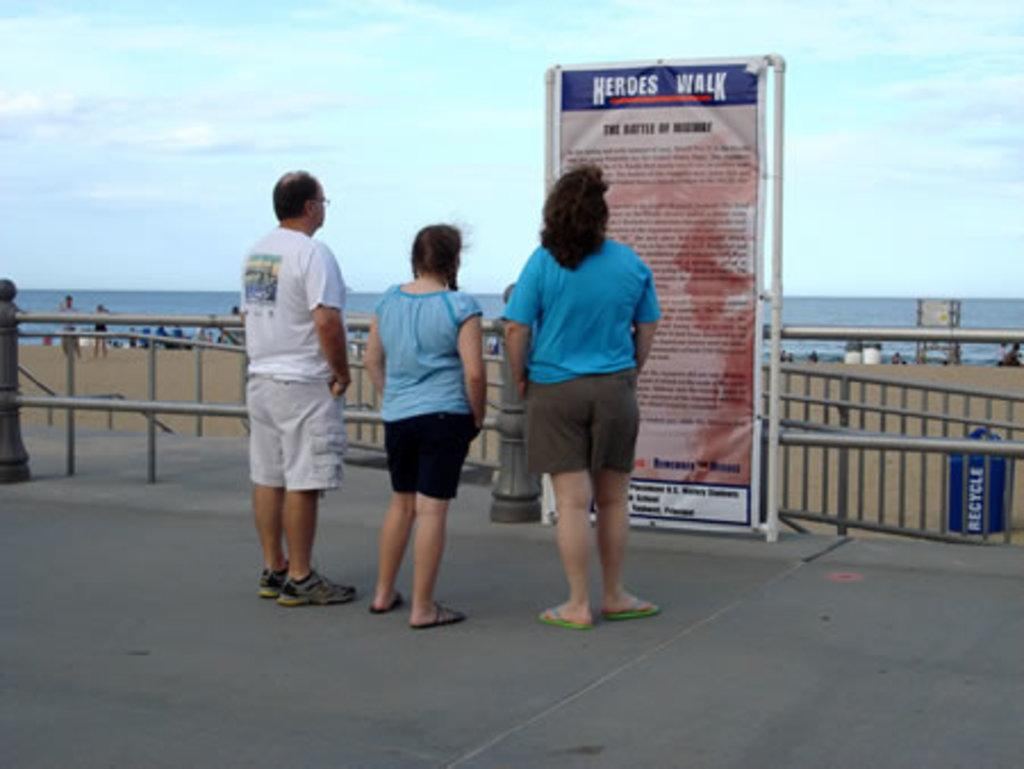What can be seen in the image involving people? There are people standing in the image. What is the purpose of the banner in the image? The purpose of the banner is not specified, but it is present in the image. What type of structure is present in the image? There is a metal railing in the image. What is used for waste disposal in the image? There is a trash bin in the image. What can be seen in the background of the image? Water and the sky are visible in the background of the image. How many clocks are visible in the image? There are no clocks present in the image. What is the temperature of the hot item in the image? There is no hot item present in the image. 